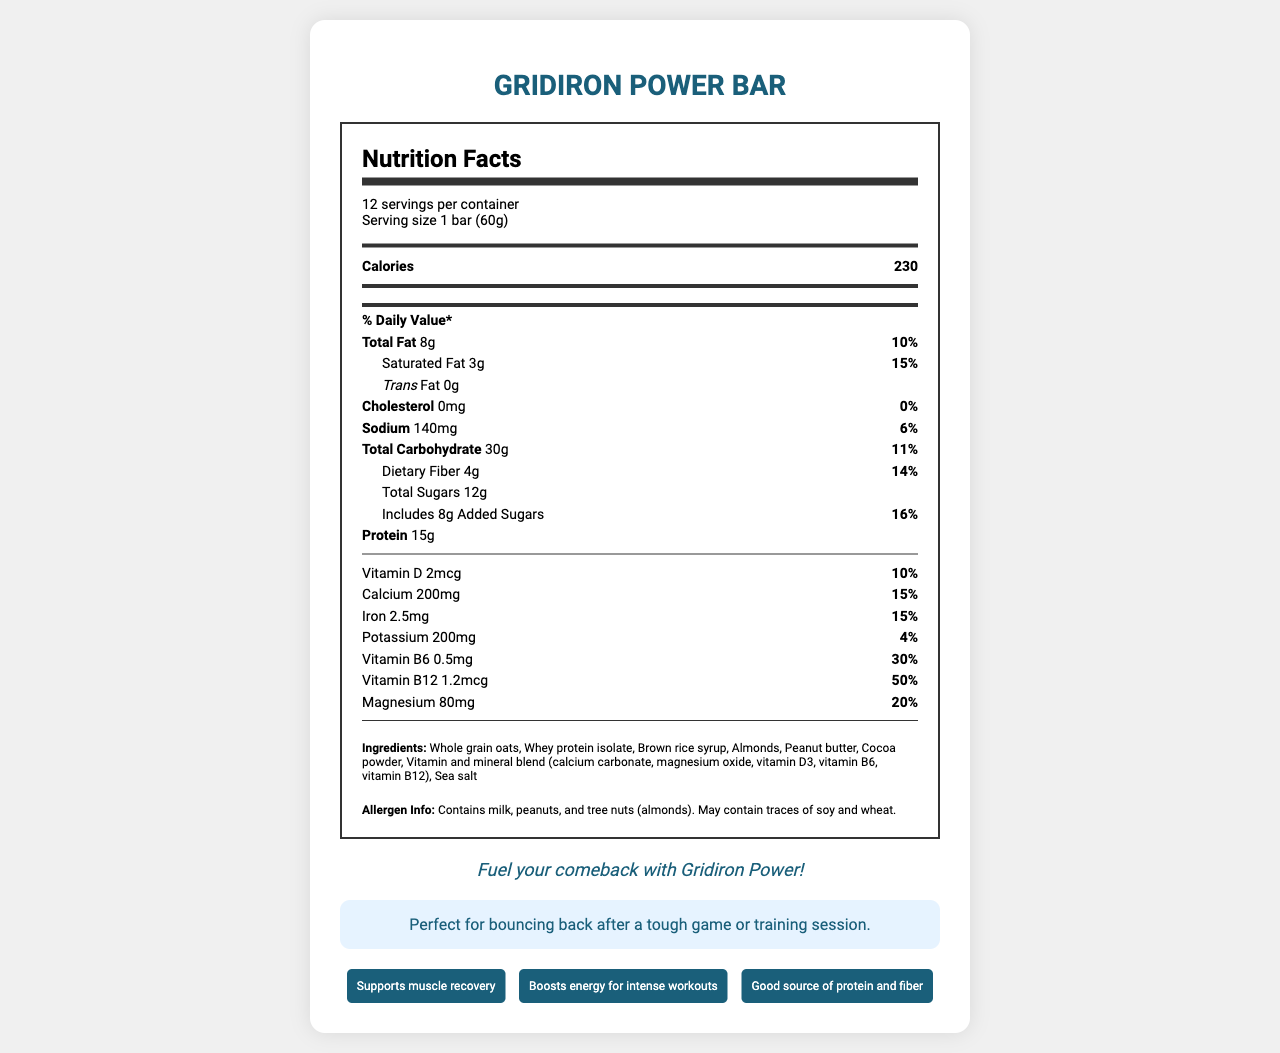what is the serving size of the Gridiron Power Bar? The serving size is indicated on the document as "1 bar (60g)".
Answer: 1 bar (60g) how many servings per container are there? The document specifies that there are "12 servings per container".
Answer: 12 what is the total fat content of one Gridiron Power Bar? The total fat content is listed as "8g" on the document.
Answer: 8g how much protein does one Gridiron Power Bar contain? The protein content per serving is highlighted as "15g".
Answer: 15g what is the % daily value of Vitamin B12 in the Gridiron Power Bar? The % daily value for Vitamin B12 is listed as "50%".
Answer: 50% how much added sugar does the Gridiron Power Bar contain? The document states that the bar includes "8g" of added sugars.
Answer: 8g what are the first three ingredients listed for the Gridiron Power Bar? The first three ingredients are listed as "Whole grain oats", "Whey protein isolate", and "Brown rice syrup".
Answer: Whole grain oats, Whey protein isolate, Brown rice syrup does the Gridiron Power Bar contain any trans fat? The trans fat content is listed as "0g".
Answer: No which of the following vitamins is present in the highest % daily value in the Gridiron Power Bar? A. Vitamin D B. Vitamin B6 C. Vitamin B12 D. Calcium Vitamin B12 has the highest % daily value at 50%, compared to others: Vitamin D (10%), Vitamin B6 (30%), and Calcium (15%).
Answer: C. Vitamin B12 how many grams of dietary fiber does the Gridiron Power Bar have? The dietary fiber content is listed as "4g".
Answer: 4g which vitamin in the Gridiron Power Bar has a daily value of 20%? A. Magnesium B. Iron C. Vitamin D Magnesium is listed with a 20% daily value in the document.
Answer: A. Magnesium what statement is made about the product's ingestible allergens? The allergen information indicates the presence of milk, peanuts, and tree nuts (almonds), and a possibility of traces of soy and wheat.
Answer: Contains milk, peanuts, and tree nuts (almonds). May contain traces of soy and wheat. describe the main focus of the Gridiron Power Bar's Nutrition Facts Label. The document thoroughly details the nutritional composition, ingredients, and health benefits of the Gridiron Power Bar.
Answer: The main focus of the document is to provide nutritional information about the Gridiron Power Bar, including serving size, calories, macronutrients, vitamins, minerals, ingredients, allergen information, and product claims. is the Gridiron Power Bar a good source of fiber? The bar contains 4g of dietary fiber, which amounts to 14% of the daily value, indicated as a good source.
Answer: Yes how much sodium does one bar contain? The sodium content per serving is listed as "140mg".
Answer: 140mg can you determine from the document whether the Gridiron Power Bar is gluten-free? The document mentions it may contain traces of wheat, but does not confirm if it is gluten-free.
Answer: Cannot be determined what is the tagline for the Gridiron Power Bar? The tagline is highlighted as "Fuel your comeback with Gridiron Power!".
Answer: Fuel your comeback with Gridiron Power! what special message is given for muscle recovery? One of the product claims is "Supports muscle recovery".
Answer: Supports muscle recovery what are some of the product claims? The listed product claims include "Supports muscle recovery", "Boosts energy for intense workouts", and "Good source of protein and fiber".
Answer: Supports muscle recovery, Boosts energy for intense workouts, Good source of protein and fiber what is the total carbohydrate content of one Gridiron Power Bar? The total carbohydrate content is listed as "30g" on the document.
Answer: 30g 